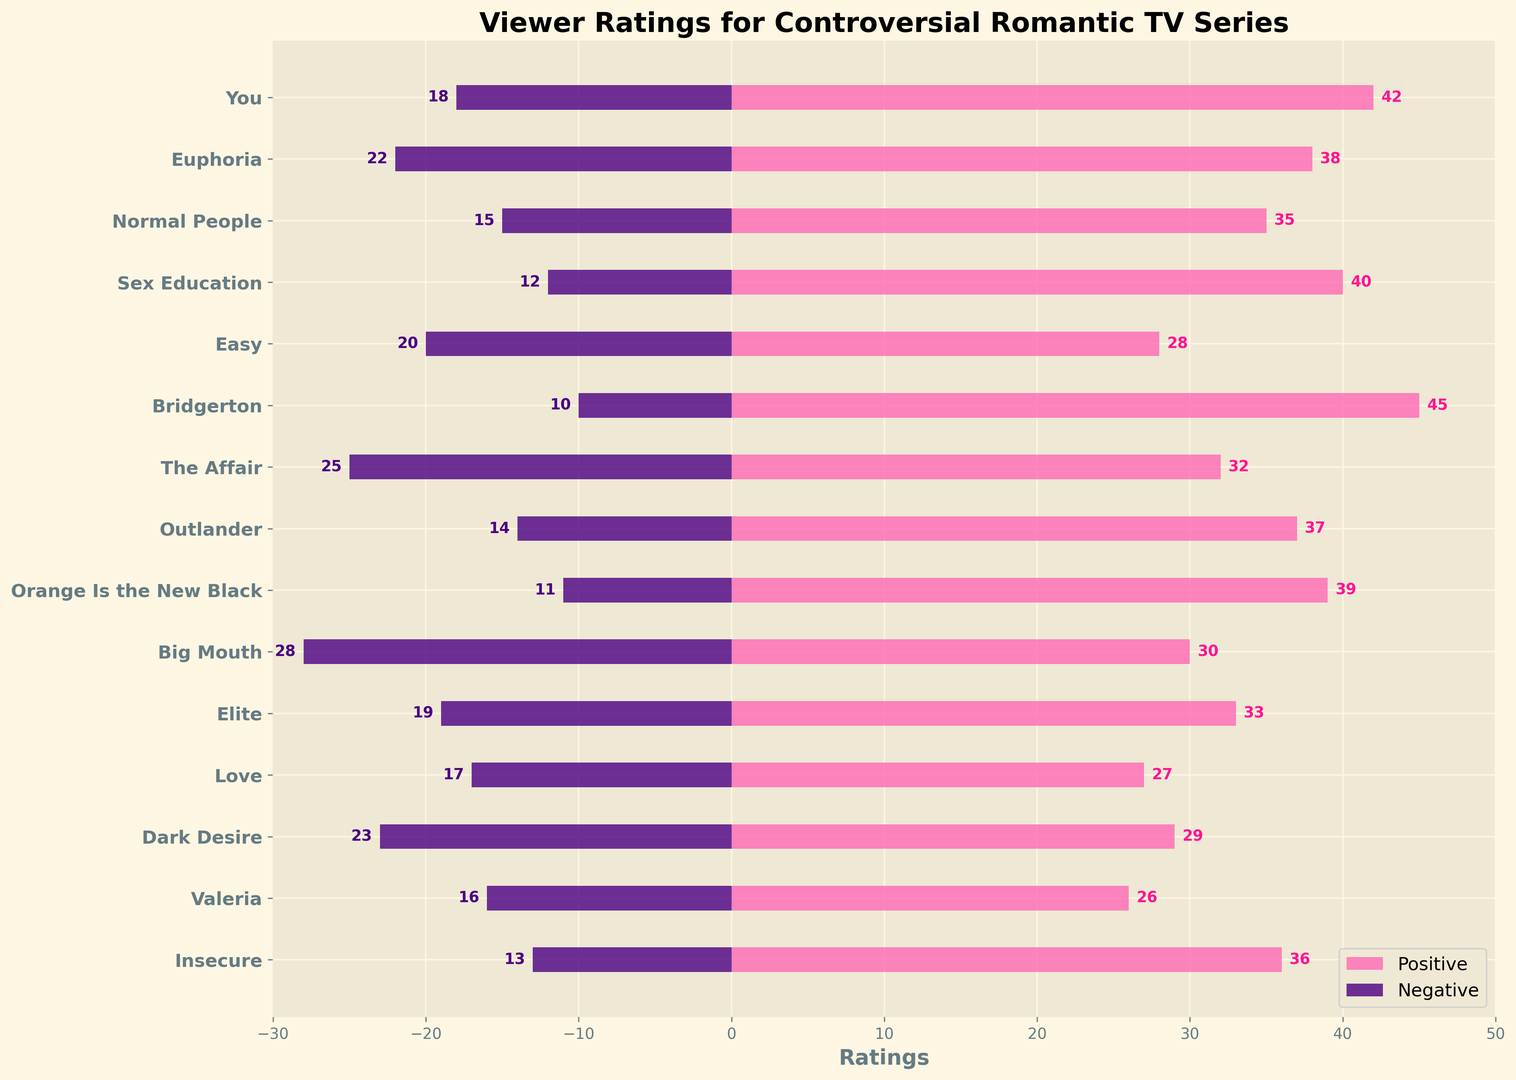Which series has the highest positive rating? The series "Bridgerton" has the highest positive rating of 45, which is the maximum value among all positive ratings displayed on the plot.
Answer: Bridgerton Which series has the most negative reviews? The series "Big Mouth" has the most negative reviews with a rating of -28, which is the lowest value among all negative ratings.
Answer: Big Mouth How many series have a positive rating greater than or equal to 40? The series with positive ratings greater than or equal to 40 are "You," "Sex Education," and "Bridgerton," making a total of 3.
Answer: 3 Which series has the smallest difference between positive and negative ratings? Calculating the differences for each series: "Normal People" has the smallest difference of 50 (35 - (-15) = 50).
Answer: Normal People What is the average positive rating of the top 3 highest-rated series? The top 3 highest-rated series in terms of positive ratings are "Bridgerton" (45), "You" (42), and "Sex Education" (40). The average is (45 + 42 + 40) / 3 = 42.33.
Answer: 42.33 Which series has a more positive rating compared to its negative rating being closer to zero? Comparing the differences: "Bridgerton" has the smallest absolute negative rating of -10, and a positive rating of 45. Thus, "Bridgerton" has a more positive rating.
Answer: Bridgerton What is the total sum of positive ratings for all series? Summing up all positive ratings: 42 + 38 + 35 + 40 + 28 + 45 + 32 + 37 + 39 + 30 + 33 + 27 + 29 + 26 + 36 = 517.
Answer: 517 Which series has a greater absolute value of negative rating: "Euphoria" or "The Affair"? The absolute values of negative ratings are 22 for "Euphoria" and 25 for "The Affair". Since 25 is greater, "The Affair" has a greater absolute value.
Answer: The Affair Which series has the closest positive rating to 35? "Normal People" has a positive rating of exactly 35, making it the closest to the given value of 35.
Answer: Normal People 